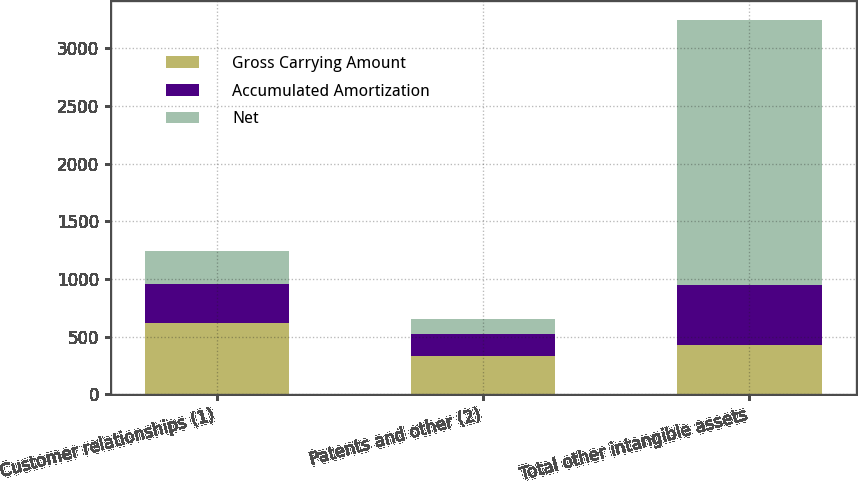<chart> <loc_0><loc_0><loc_500><loc_500><stacked_bar_chart><ecel><fcel>Customer relationships (1)<fcel>Patents and other (2)<fcel>Total other intangible assets<nl><fcel>Gross Carrying Amount<fcel>622<fcel>328<fcel>423<nl><fcel>Accumulated Amortization<fcel>330<fcel>197<fcel>527<nl><fcel>Net<fcel>292<fcel>131<fcel>2296<nl></chart> 